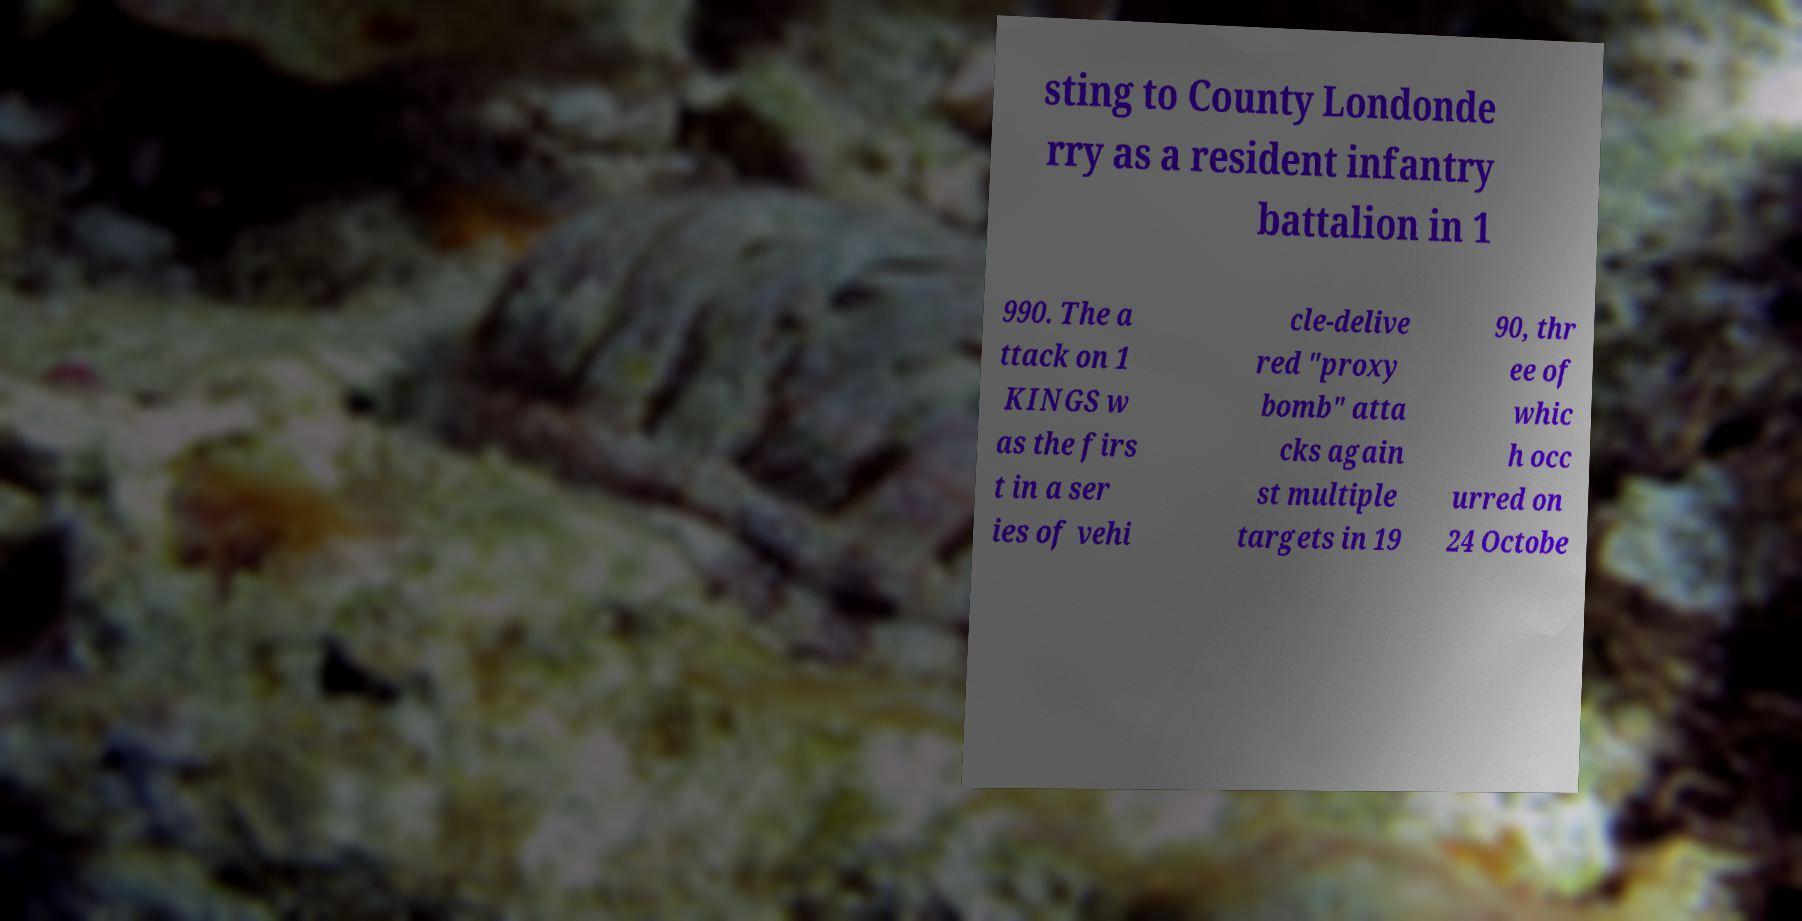I need the written content from this picture converted into text. Can you do that? sting to County Londonde rry as a resident infantry battalion in 1 990. The a ttack on 1 KINGS w as the firs t in a ser ies of vehi cle-delive red "proxy bomb" atta cks again st multiple targets in 19 90, thr ee of whic h occ urred on 24 Octobe 